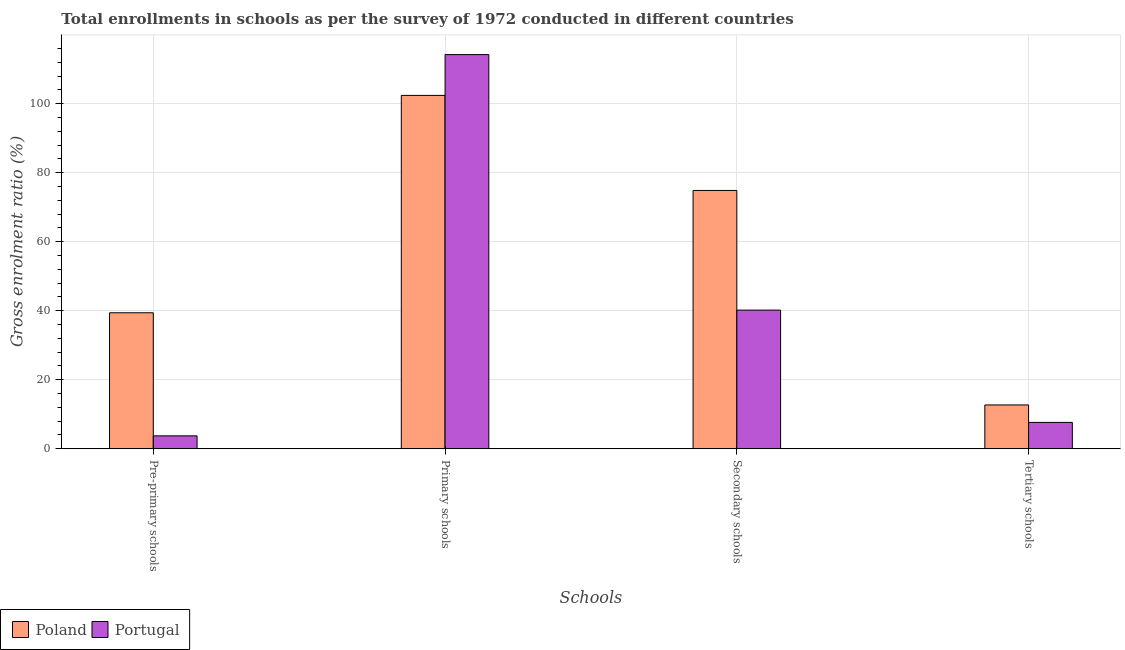Are the number of bars per tick equal to the number of legend labels?
Give a very brief answer. Yes. What is the label of the 3rd group of bars from the left?
Your answer should be very brief. Secondary schools. What is the gross enrolment ratio in primary schools in Poland?
Offer a very short reply. 102.43. Across all countries, what is the maximum gross enrolment ratio in secondary schools?
Offer a very short reply. 74.86. Across all countries, what is the minimum gross enrolment ratio in secondary schools?
Ensure brevity in your answer.  40.17. What is the total gross enrolment ratio in secondary schools in the graph?
Make the answer very short. 115.04. What is the difference between the gross enrolment ratio in pre-primary schools in Portugal and that in Poland?
Give a very brief answer. -35.68. What is the difference between the gross enrolment ratio in secondary schools in Portugal and the gross enrolment ratio in tertiary schools in Poland?
Your answer should be compact. 27.49. What is the average gross enrolment ratio in secondary schools per country?
Your answer should be compact. 57.52. What is the difference between the gross enrolment ratio in pre-primary schools and gross enrolment ratio in secondary schools in Poland?
Ensure brevity in your answer.  -35.46. What is the ratio of the gross enrolment ratio in tertiary schools in Poland to that in Portugal?
Your response must be concise. 1.66. Is the difference between the gross enrolment ratio in primary schools in Poland and Portugal greater than the difference between the gross enrolment ratio in secondary schools in Poland and Portugal?
Your answer should be very brief. No. What is the difference between the highest and the second highest gross enrolment ratio in primary schools?
Keep it short and to the point. 11.83. What is the difference between the highest and the lowest gross enrolment ratio in secondary schools?
Provide a short and direct response. 34.69. How many bars are there?
Give a very brief answer. 8. Are all the bars in the graph horizontal?
Give a very brief answer. No. What is the difference between two consecutive major ticks on the Y-axis?
Make the answer very short. 20. Where does the legend appear in the graph?
Ensure brevity in your answer.  Bottom left. How many legend labels are there?
Ensure brevity in your answer.  2. What is the title of the graph?
Offer a very short reply. Total enrollments in schools as per the survey of 1972 conducted in different countries. What is the label or title of the X-axis?
Your answer should be compact. Schools. What is the label or title of the Y-axis?
Offer a very short reply. Gross enrolment ratio (%). What is the Gross enrolment ratio (%) in Poland in Pre-primary schools?
Your response must be concise. 39.4. What is the Gross enrolment ratio (%) of Portugal in Pre-primary schools?
Your response must be concise. 3.72. What is the Gross enrolment ratio (%) in Poland in Primary schools?
Provide a short and direct response. 102.43. What is the Gross enrolment ratio (%) in Portugal in Primary schools?
Offer a very short reply. 114.26. What is the Gross enrolment ratio (%) in Poland in Secondary schools?
Your answer should be compact. 74.86. What is the Gross enrolment ratio (%) in Portugal in Secondary schools?
Offer a terse response. 40.17. What is the Gross enrolment ratio (%) of Poland in Tertiary schools?
Your answer should be very brief. 12.68. What is the Gross enrolment ratio (%) of Portugal in Tertiary schools?
Give a very brief answer. 7.62. Across all Schools, what is the maximum Gross enrolment ratio (%) in Poland?
Offer a terse response. 102.43. Across all Schools, what is the maximum Gross enrolment ratio (%) in Portugal?
Offer a very short reply. 114.26. Across all Schools, what is the minimum Gross enrolment ratio (%) of Poland?
Offer a terse response. 12.68. Across all Schools, what is the minimum Gross enrolment ratio (%) of Portugal?
Make the answer very short. 3.72. What is the total Gross enrolment ratio (%) in Poland in the graph?
Provide a succinct answer. 229.37. What is the total Gross enrolment ratio (%) of Portugal in the graph?
Ensure brevity in your answer.  165.77. What is the difference between the Gross enrolment ratio (%) of Poland in Pre-primary schools and that in Primary schools?
Keep it short and to the point. -63.02. What is the difference between the Gross enrolment ratio (%) in Portugal in Pre-primary schools and that in Primary schools?
Provide a succinct answer. -110.54. What is the difference between the Gross enrolment ratio (%) of Poland in Pre-primary schools and that in Secondary schools?
Offer a very short reply. -35.46. What is the difference between the Gross enrolment ratio (%) of Portugal in Pre-primary schools and that in Secondary schools?
Make the answer very short. -36.45. What is the difference between the Gross enrolment ratio (%) of Poland in Pre-primary schools and that in Tertiary schools?
Offer a terse response. 26.72. What is the difference between the Gross enrolment ratio (%) in Portugal in Pre-primary schools and that in Tertiary schools?
Offer a very short reply. -3.9. What is the difference between the Gross enrolment ratio (%) of Poland in Primary schools and that in Secondary schools?
Your answer should be very brief. 27.56. What is the difference between the Gross enrolment ratio (%) in Portugal in Primary schools and that in Secondary schools?
Your answer should be very brief. 74.08. What is the difference between the Gross enrolment ratio (%) in Poland in Primary schools and that in Tertiary schools?
Ensure brevity in your answer.  89.75. What is the difference between the Gross enrolment ratio (%) of Portugal in Primary schools and that in Tertiary schools?
Provide a succinct answer. 106.64. What is the difference between the Gross enrolment ratio (%) of Poland in Secondary schools and that in Tertiary schools?
Offer a very short reply. 62.18. What is the difference between the Gross enrolment ratio (%) in Portugal in Secondary schools and that in Tertiary schools?
Your answer should be very brief. 32.56. What is the difference between the Gross enrolment ratio (%) of Poland in Pre-primary schools and the Gross enrolment ratio (%) of Portugal in Primary schools?
Provide a short and direct response. -74.85. What is the difference between the Gross enrolment ratio (%) of Poland in Pre-primary schools and the Gross enrolment ratio (%) of Portugal in Secondary schools?
Make the answer very short. -0.77. What is the difference between the Gross enrolment ratio (%) of Poland in Pre-primary schools and the Gross enrolment ratio (%) of Portugal in Tertiary schools?
Keep it short and to the point. 31.79. What is the difference between the Gross enrolment ratio (%) in Poland in Primary schools and the Gross enrolment ratio (%) in Portugal in Secondary schools?
Ensure brevity in your answer.  62.25. What is the difference between the Gross enrolment ratio (%) of Poland in Primary schools and the Gross enrolment ratio (%) of Portugal in Tertiary schools?
Give a very brief answer. 94.81. What is the difference between the Gross enrolment ratio (%) of Poland in Secondary schools and the Gross enrolment ratio (%) of Portugal in Tertiary schools?
Provide a short and direct response. 67.25. What is the average Gross enrolment ratio (%) of Poland per Schools?
Make the answer very short. 57.34. What is the average Gross enrolment ratio (%) in Portugal per Schools?
Ensure brevity in your answer.  41.44. What is the difference between the Gross enrolment ratio (%) in Poland and Gross enrolment ratio (%) in Portugal in Pre-primary schools?
Your response must be concise. 35.68. What is the difference between the Gross enrolment ratio (%) in Poland and Gross enrolment ratio (%) in Portugal in Primary schools?
Keep it short and to the point. -11.83. What is the difference between the Gross enrolment ratio (%) of Poland and Gross enrolment ratio (%) of Portugal in Secondary schools?
Your answer should be very brief. 34.69. What is the difference between the Gross enrolment ratio (%) in Poland and Gross enrolment ratio (%) in Portugal in Tertiary schools?
Your response must be concise. 5.06. What is the ratio of the Gross enrolment ratio (%) of Poland in Pre-primary schools to that in Primary schools?
Your answer should be very brief. 0.38. What is the ratio of the Gross enrolment ratio (%) of Portugal in Pre-primary schools to that in Primary schools?
Make the answer very short. 0.03. What is the ratio of the Gross enrolment ratio (%) of Poland in Pre-primary schools to that in Secondary schools?
Make the answer very short. 0.53. What is the ratio of the Gross enrolment ratio (%) of Portugal in Pre-primary schools to that in Secondary schools?
Your answer should be very brief. 0.09. What is the ratio of the Gross enrolment ratio (%) of Poland in Pre-primary schools to that in Tertiary schools?
Your answer should be compact. 3.11. What is the ratio of the Gross enrolment ratio (%) of Portugal in Pre-primary schools to that in Tertiary schools?
Your response must be concise. 0.49. What is the ratio of the Gross enrolment ratio (%) of Poland in Primary schools to that in Secondary schools?
Ensure brevity in your answer.  1.37. What is the ratio of the Gross enrolment ratio (%) of Portugal in Primary schools to that in Secondary schools?
Your answer should be very brief. 2.84. What is the ratio of the Gross enrolment ratio (%) of Poland in Primary schools to that in Tertiary schools?
Provide a short and direct response. 8.08. What is the ratio of the Gross enrolment ratio (%) in Portugal in Primary schools to that in Tertiary schools?
Provide a succinct answer. 15. What is the ratio of the Gross enrolment ratio (%) in Poland in Secondary schools to that in Tertiary schools?
Provide a short and direct response. 5.9. What is the ratio of the Gross enrolment ratio (%) in Portugal in Secondary schools to that in Tertiary schools?
Give a very brief answer. 5.27. What is the difference between the highest and the second highest Gross enrolment ratio (%) in Poland?
Give a very brief answer. 27.56. What is the difference between the highest and the second highest Gross enrolment ratio (%) of Portugal?
Provide a succinct answer. 74.08. What is the difference between the highest and the lowest Gross enrolment ratio (%) in Poland?
Your answer should be compact. 89.75. What is the difference between the highest and the lowest Gross enrolment ratio (%) in Portugal?
Offer a terse response. 110.54. 